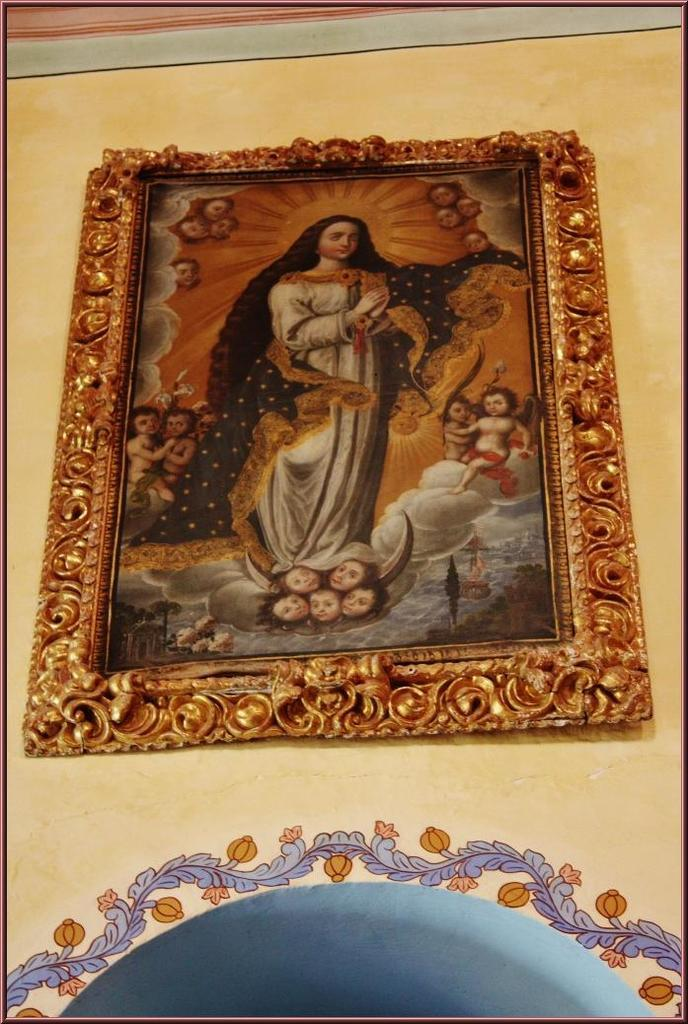What is hanging on the wall in the image? There is a photo frame on the wall. What is inside the photo frame? A woman is standing in the photo frame. What is the woman wearing in the photo frame? The woman is wearing a white dress. What else can be seen on the right side of the image? There is a baby on the right side of the image. What type of stamp can be seen on the woman's dress in the image? There is no stamp visible on the woman's dress in the image. 